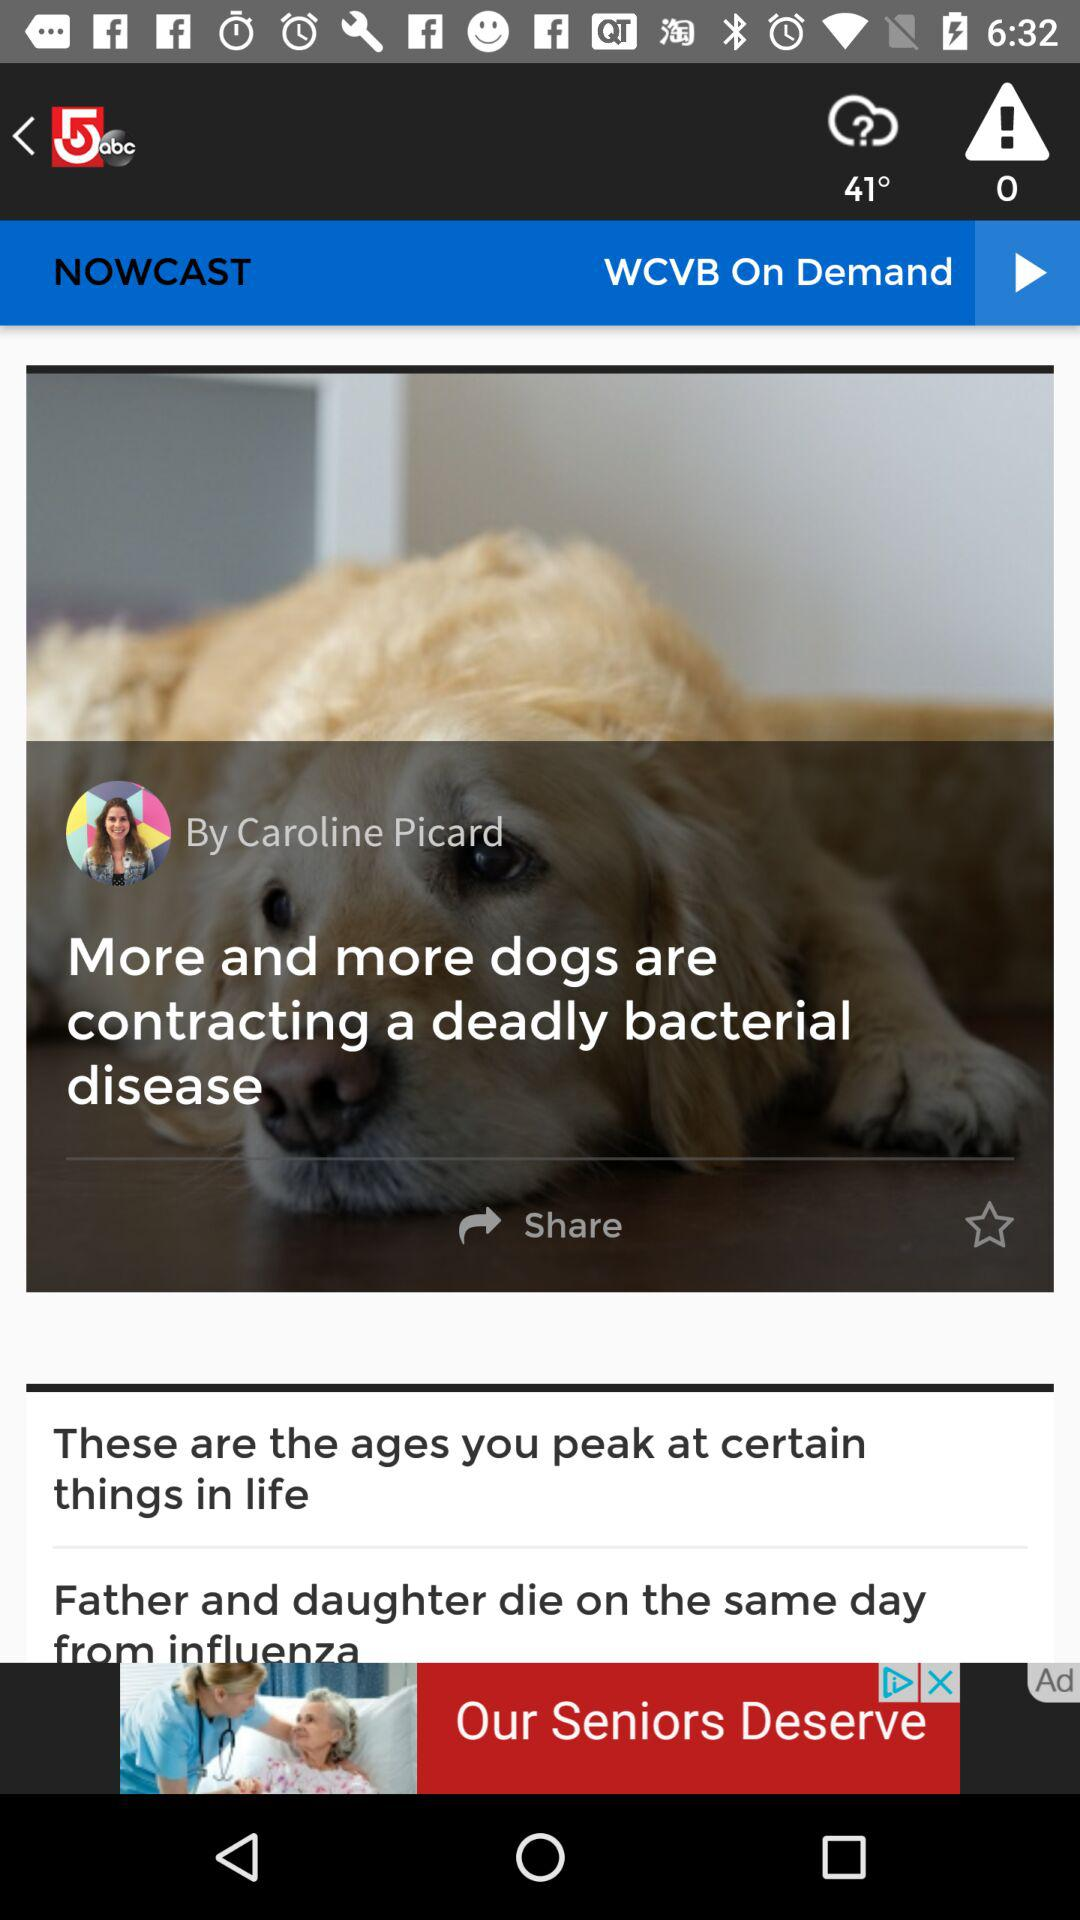What is the title of the news? The titles are "More and more dogs are contracting a deadly bacterial disease", "These are the ages you peak at certain things in life" and "Father and daughter die on the same day from influenza". 